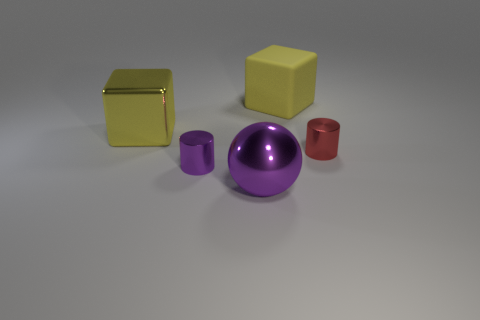What number of objects are big blocks in front of the large yellow matte cube or big yellow things behind the yellow metal cube?
Your response must be concise. 2. What is the color of the ball?
Provide a short and direct response. Purple. What number of small red cylinders have the same material as the large ball?
Keep it short and to the point. 1. Are there more brown rubber blocks than tiny red cylinders?
Offer a terse response. No. What number of big things are to the right of the cylinder in front of the tiny red metallic cylinder?
Ensure brevity in your answer.  2. How many things are either shiny objects behind the purple ball or green cylinders?
Offer a very short reply. 3. Is there a blue rubber object of the same shape as the small purple object?
Give a very brief answer. No. What shape is the metallic thing behind the shiny cylinder to the right of the yellow matte block?
Provide a short and direct response. Cube. What number of cubes are either matte objects or small red metallic things?
Offer a terse response. 1. There is a small object that is the same color as the metal ball; what is it made of?
Provide a succinct answer. Metal. 